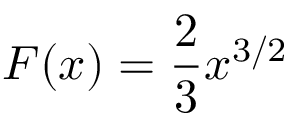<formula> <loc_0><loc_0><loc_500><loc_500>F ( x ) = { \frac { 2 } { 3 } } x ^ { 3 / 2 }</formula> 